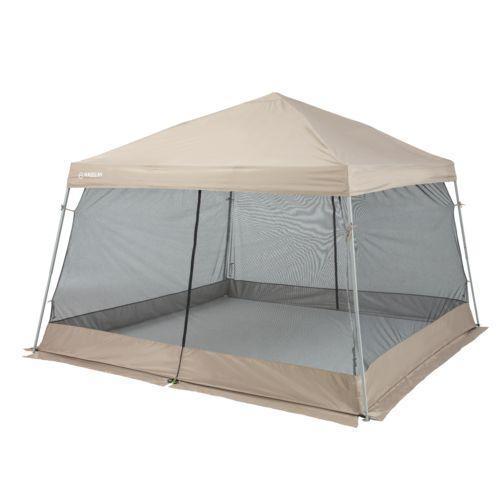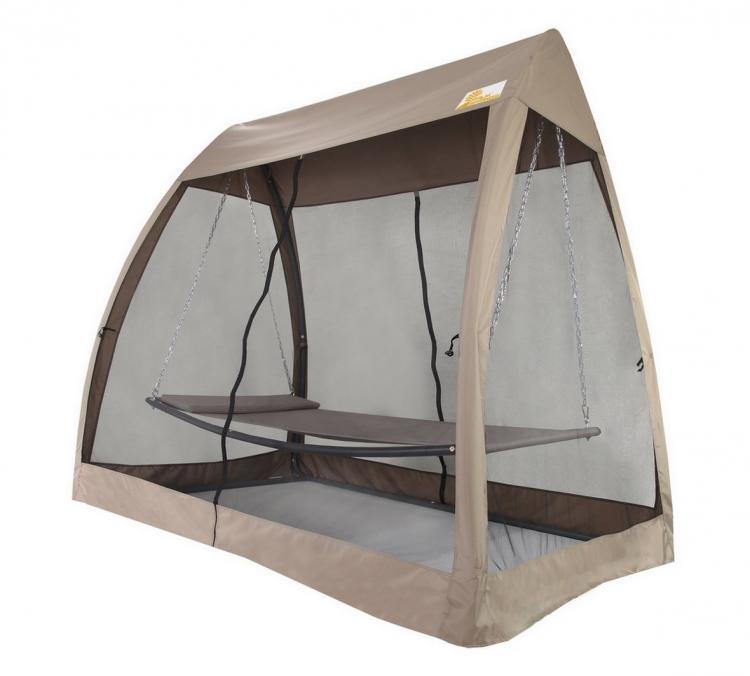The first image is the image on the left, the second image is the image on the right. For the images displayed, is the sentence "Both tents are shown without a background." factually correct? Answer yes or no. Yes. The first image is the image on the left, the second image is the image on the right. Evaluate the accuracy of this statement regarding the images: "The structure in one of the images is standing upon a tiled floor.". Is it true? Answer yes or no. No. 